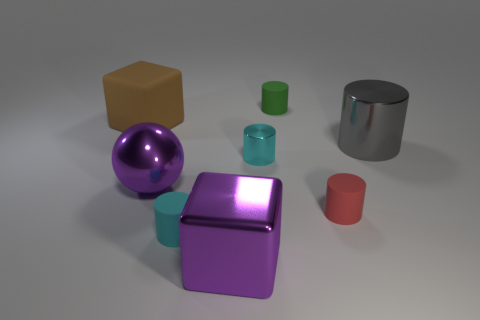Subtract all gray spheres. How many cyan cylinders are left? 2 Subtract all tiny cyan rubber cylinders. How many cylinders are left? 4 Subtract all green cylinders. How many cylinders are left? 4 Subtract 1 cylinders. How many cylinders are left? 4 Add 2 big purple cubes. How many objects exist? 10 Subtract all purple cylinders. Subtract all cyan cubes. How many cylinders are left? 5 Subtract all spheres. How many objects are left? 7 Subtract all red matte objects. Subtract all small metallic objects. How many objects are left? 6 Add 6 green things. How many green things are left? 7 Add 6 purple things. How many purple things exist? 8 